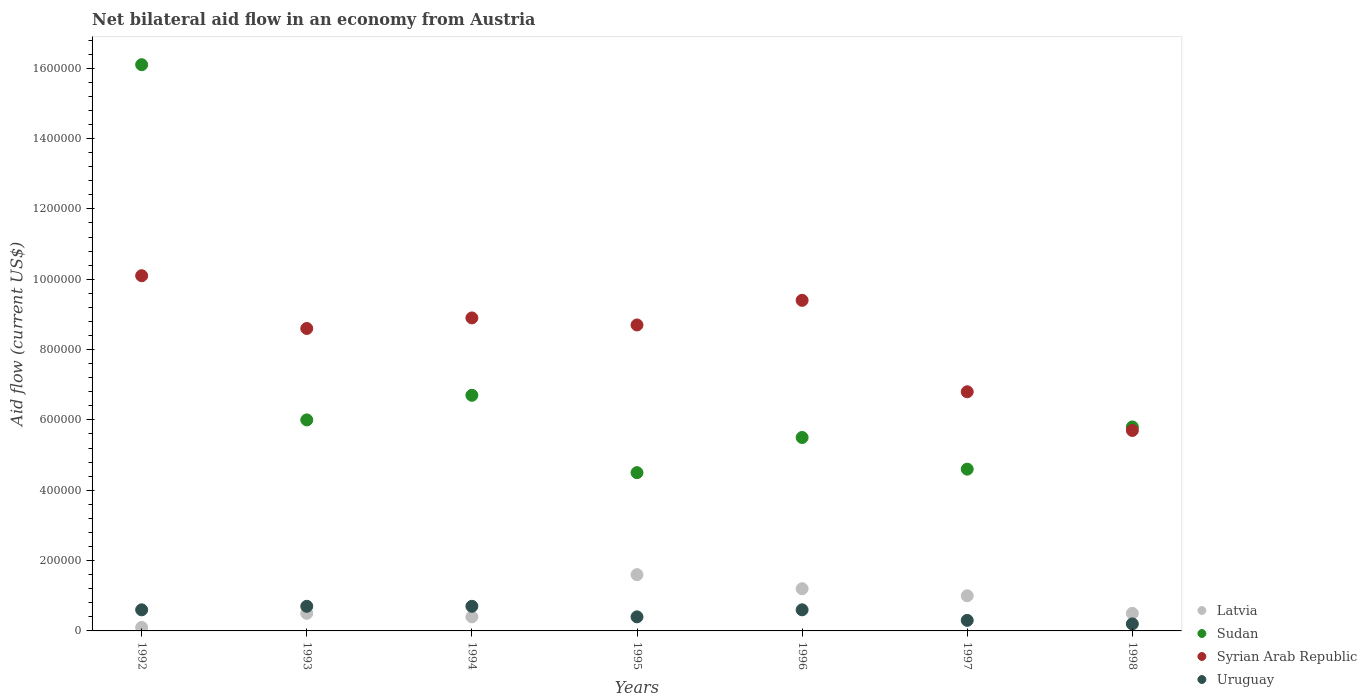Is the number of dotlines equal to the number of legend labels?
Give a very brief answer. Yes. What is the net bilateral aid flow in Syrian Arab Republic in 1997?
Provide a short and direct response. 6.80e+05. Across all years, what is the maximum net bilateral aid flow in Sudan?
Offer a terse response. 1.61e+06. Across all years, what is the minimum net bilateral aid flow in Sudan?
Offer a very short reply. 4.50e+05. In which year was the net bilateral aid flow in Sudan minimum?
Your answer should be very brief. 1995. What is the total net bilateral aid flow in Sudan in the graph?
Your response must be concise. 4.92e+06. What is the difference between the net bilateral aid flow in Uruguay in 1992 and that in 1998?
Offer a very short reply. 4.00e+04. What is the difference between the net bilateral aid flow in Sudan in 1998 and the net bilateral aid flow in Uruguay in 1994?
Keep it short and to the point. 5.10e+05. What is the average net bilateral aid flow in Latvia per year?
Offer a terse response. 7.57e+04. In the year 1998, what is the difference between the net bilateral aid flow in Syrian Arab Republic and net bilateral aid flow in Uruguay?
Your answer should be very brief. 5.50e+05. In how many years, is the net bilateral aid flow in Sudan greater than 880000 US$?
Your answer should be very brief. 1. What is the ratio of the net bilateral aid flow in Syrian Arab Republic in 1995 to that in 1998?
Your response must be concise. 1.53. Is the net bilateral aid flow in Sudan in 1993 less than that in 1998?
Your answer should be compact. No. What is the difference between the highest and the second highest net bilateral aid flow in Sudan?
Your answer should be very brief. 9.40e+05. What is the difference between the highest and the lowest net bilateral aid flow in Syrian Arab Republic?
Provide a succinct answer. 4.40e+05. In how many years, is the net bilateral aid flow in Uruguay greater than the average net bilateral aid flow in Uruguay taken over all years?
Your response must be concise. 4. Is it the case that in every year, the sum of the net bilateral aid flow in Syrian Arab Republic and net bilateral aid flow in Sudan  is greater than the sum of net bilateral aid flow in Uruguay and net bilateral aid flow in Latvia?
Offer a very short reply. Yes. Does the net bilateral aid flow in Sudan monotonically increase over the years?
Your answer should be very brief. No. Is the net bilateral aid flow in Uruguay strictly less than the net bilateral aid flow in Sudan over the years?
Your response must be concise. Yes. How many years are there in the graph?
Ensure brevity in your answer.  7. What is the difference between two consecutive major ticks on the Y-axis?
Your answer should be compact. 2.00e+05. Where does the legend appear in the graph?
Keep it short and to the point. Bottom right. How many legend labels are there?
Ensure brevity in your answer.  4. How are the legend labels stacked?
Your answer should be compact. Vertical. What is the title of the graph?
Keep it short and to the point. Net bilateral aid flow in an economy from Austria. Does "Netherlands" appear as one of the legend labels in the graph?
Give a very brief answer. No. What is the label or title of the Y-axis?
Offer a terse response. Aid flow (current US$). What is the Aid flow (current US$) in Sudan in 1992?
Offer a terse response. 1.61e+06. What is the Aid flow (current US$) in Syrian Arab Republic in 1992?
Your answer should be very brief. 1.01e+06. What is the Aid flow (current US$) of Latvia in 1993?
Your response must be concise. 5.00e+04. What is the Aid flow (current US$) in Syrian Arab Republic in 1993?
Give a very brief answer. 8.60e+05. What is the Aid flow (current US$) in Latvia in 1994?
Provide a short and direct response. 4.00e+04. What is the Aid flow (current US$) of Sudan in 1994?
Your answer should be very brief. 6.70e+05. What is the Aid flow (current US$) of Syrian Arab Republic in 1994?
Offer a very short reply. 8.90e+05. What is the Aid flow (current US$) of Latvia in 1995?
Your response must be concise. 1.60e+05. What is the Aid flow (current US$) in Sudan in 1995?
Provide a short and direct response. 4.50e+05. What is the Aid flow (current US$) of Syrian Arab Republic in 1995?
Make the answer very short. 8.70e+05. What is the Aid flow (current US$) in Uruguay in 1995?
Your answer should be compact. 4.00e+04. What is the Aid flow (current US$) of Sudan in 1996?
Give a very brief answer. 5.50e+05. What is the Aid flow (current US$) of Syrian Arab Republic in 1996?
Provide a short and direct response. 9.40e+05. What is the Aid flow (current US$) of Syrian Arab Republic in 1997?
Give a very brief answer. 6.80e+05. What is the Aid flow (current US$) in Uruguay in 1997?
Provide a short and direct response. 3.00e+04. What is the Aid flow (current US$) of Sudan in 1998?
Your answer should be compact. 5.80e+05. What is the Aid flow (current US$) in Syrian Arab Republic in 1998?
Provide a succinct answer. 5.70e+05. Across all years, what is the maximum Aid flow (current US$) in Sudan?
Provide a succinct answer. 1.61e+06. Across all years, what is the maximum Aid flow (current US$) of Syrian Arab Republic?
Provide a short and direct response. 1.01e+06. Across all years, what is the minimum Aid flow (current US$) of Latvia?
Your answer should be very brief. 10000. Across all years, what is the minimum Aid flow (current US$) in Sudan?
Your answer should be very brief. 4.50e+05. Across all years, what is the minimum Aid flow (current US$) of Syrian Arab Republic?
Keep it short and to the point. 5.70e+05. What is the total Aid flow (current US$) of Latvia in the graph?
Your answer should be compact. 5.30e+05. What is the total Aid flow (current US$) of Sudan in the graph?
Give a very brief answer. 4.92e+06. What is the total Aid flow (current US$) of Syrian Arab Republic in the graph?
Give a very brief answer. 5.82e+06. What is the total Aid flow (current US$) of Uruguay in the graph?
Ensure brevity in your answer.  3.50e+05. What is the difference between the Aid flow (current US$) in Sudan in 1992 and that in 1993?
Give a very brief answer. 1.01e+06. What is the difference between the Aid flow (current US$) of Syrian Arab Republic in 1992 and that in 1993?
Your response must be concise. 1.50e+05. What is the difference between the Aid flow (current US$) in Uruguay in 1992 and that in 1993?
Make the answer very short. -10000. What is the difference between the Aid flow (current US$) of Sudan in 1992 and that in 1994?
Provide a short and direct response. 9.40e+05. What is the difference between the Aid flow (current US$) of Uruguay in 1992 and that in 1994?
Provide a succinct answer. -10000. What is the difference between the Aid flow (current US$) in Sudan in 1992 and that in 1995?
Provide a succinct answer. 1.16e+06. What is the difference between the Aid flow (current US$) of Uruguay in 1992 and that in 1995?
Offer a terse response. 2.00e+04. What is the difference between the Aid flow (current US$) in Sudan in 1992 and that in 1996?
Your answer should be very brief. 1.06e+06. What is the difference between the Aid flow (current US$) in Syrian Arab Republic in 1992 and that in 1996?
Provide a succinct answer. 7.00e+04. What is the difference between the Aid flow (current US$) in Sudan in 1992 and that in 1997?
Give a very brief answer. 1.15e+06. What is the difference between the Aid flow (current US$) in Syrian Arab Republic in 1992 and that in 1997?
Offer a very short reply. 3.30e+05. What is the difference between the Aid flow (current US$) of Latvia in 1992 and that in 1998?
Your response must be concise. -4.00e+04. What is the difference between the Aid flow (current US$) in Sudan in 1992 and that in 1998?
Provide a short and direct response. 1.03e+06. What is the difference between the Aid flow (current US$) in Syrian Arab Republic in 1992 and that in 1998?
Your response must be concise. 4.40e+05. What is the difference between the Aid flow (current US$) in Uruguay in 1992 and that in 1998?
Offer a terse response. 4.00e+04. What is the difference between the Aid flow (current US$) in Latvia in 1993 and that in 1994?
Make the answer very short. 10000. What is the difference between the Aid flow (current US$) in Uruguay in 1993 and that in 1994?
Offer a terse response. 0. What is the difference between the Aid flow (current US$) of Sudan in 1993 and that in 1995?
Your response must be concise. 1.50e+05. What is the difference between the Aid flow (current US$) of Latvia in 1993 and that in 1996?
Ensure brevity in your answer.  -7.00e+04. What is the difference between the Aid flow (current US$) in Syrian Arab Republic in 1993 and that in 1996?
Ensure brevity in your answer.  -8.00e+04. What is the difference between the Aid flow (current US$) of Syrian Arab Republic in 1993 and that in 1997?
Provide a short and direct response. 1.80e+05. What is the difference between the Aid flow (current US$) of Uruguay in 1993 and that in 1997?
Your answer should be very brief. 4.00e+04. What is the difference between the Aid flow (current US$) of Latvia in 1993 and that in 1998?
Make the answer very short. 0. What is the difference between the Aid flow (current US$) of Syrian Arab Republic in 1993 and that in 1998?
Keep it short and to the point. 2.90e+05. What is the difference between the Aid flow (current US$) of Uruguay in 1993 and that in 1998?
Provide a short and direct response. 5.00e+04. What is the difference between the Aid flow (current US$) in Sudan in 1994 and that in 1995?
Your answer should be very brief. 2.20e+05. What is the difference between the Aid flow (current US$) in Syrian Arab Republic in 1994 and that in 1995?
Your answer should be very brief. 2.00e+04. What is the difference between the Aid flow (current US$) in Syrian Arab Republic in 1994 and that in 1996?
Offer a very short reply. -5.00e+04. What is the difference between the Aid flow (current US$) of Latvia in 1994 and that in 1997?
Your response must be concise. -6.00e+04. What is the difference between the Aid flow (current US$) of Sudan in 1994 and that in 1997?
Make the answer very short. 2.10e+05. What is the difference between the Aid flow (current US$) of Uruguay in 1994 and that in 1997?
Provide a succinct answer. 4.00e+04. What is the difference between the Aid flow (current US$) in Latvia in 1994 and that in 1998?
Your answer should be very brief. -10000. What is the difference between the Aid flow (current US$) in Sudan in 1994 and that in 1998?
Provide a succinct answer. 9.00e+04. What is the difference between the Aid flow (current US$) in Latvia in 1995 and that in 1996?
Offer a very short reply. 4.00e+04. What is the difference between the Aid flow (current US$) of Syrian Arab Republic in 1995 and that in 1996?
Provide a short and direct response. -7.00e+04. What is the difference between the Aid flow (current US$) of Latvia in 1995 and that in 1997?
Ensure brevity in your answer.  6.00e+04. What is the difference between the Aid flow (current US$) in Sudan in 1995 and that in 1998?
Offer a very short reply. -1.30e+05. What is the difference between the Aid flow (current US$) in Syrian Arab Republic in 1995 and that in 1998?
Provide a short and direct response. 3.00e+05. What is the difference between the Aid flow (current US$) of Sudan in 1996 and that in 1997?
Your answer should be very brief. 9.00e+04. What is the difference between the Aid flow (current US$) of Latvia in 1996 and that in 1998?
Ensure brevity in your answer.  7.00e+04. What is the difference between the Aid flow (current US$) of Uruguay in 1996 and that in 1998?
Provide a succinct answer. 4.00e+04. What is the difference between the Aid flow (current US$) of Latvia in 1997 and that in 1998?
Keep it short and to the point. 5.00e+04. What is the difference between the Aid flow (current US$) of Sudan in 1997 and that in 1998?
Give a very brief answer. -1.20e+05. What is the difference between the Aid flow (current US$) of Latvia in 1992 and the Aid flow (current US$) of Sudan in 1993?
Your response must be concise. -5.90e+05. What is the difference between the Aid flow (current US$) in Latvia in 1992 and the Aid flow (current US$) in Syrian Arab Republic in 1993?
Your answer should be compact. -8.50e+05. What is the difference between the Aid flow (current US$) of Sudan in 1992 and the Aid flow (current US$) of Syrian Arab Republic in 1993?
Give a very brief answer. 7.50e+05. What is the difference between the Aid flow (current US$) of Sudan in 1992 and the Aid flow (current US$) of Uruguay in 1993?
Provide a succinct answer. 1.54e+06. What is the difference between the Aid flow (current US$) of Syrian Arab Republic in 1992 and the Aid flow (current US$) of Uruguay in 1993?
Make the answer very short. 9.40e+05. What is the difference between the Aid flow (current US$) of Latvia in 1992 and the Aid flow (current US$) of Sudan in 1994?
Your answer should be very brief. -6.60e+05. What is the difference between the Aid flow (current US$) in Latvia in 1992 and the Aid flow (current US$) in Syrian Arab Republic in 1994?
Offer a very short reply. -8.80e+05. What is the difference between the Aid flow (current US$) of Sudan in 1992 and the Aid flow (current US$) of Syrian Arab Republic in 1994?
Provide a short and direct response. 7.20e+05. What is the difference between the Aid flow (current US$) of Sudan in 1992 and the Aid flow (current US$) of Uruguay in 1994?
Keep it short and to the point. 1.54e+06. What is the difference between the Aid flow (current US$) of Syrian Arab Republic in 1992 and the Aid flow (current US$) of Uruguay in 1994?
Your answer should be very brief. 9.40e+05. What is the difference between the Aid flow (current US$) of Latvia in 1992 and the Aid flow (current US$) of Sudan in 1995?
Offer a very short reply. -4.40e+05. What is the difference between the Aid flow (current US$) in Latvia in 1992 and the Aid flow (current US$) in Syrian Arab Republic in 1995?
Your response must be concise. -8.60e+05. What is the difference between the Aid flow (current US$) in Sudan in 1992 and the Aid flow (current US$) in Syrian Arab Republic in 1995?
Provide a succinct answer. 7.40e+05. What is the difference between the Aid flow (current US$) of Sudan in 1992 and the Aid flow (current US$) of Uruguay in 1995?
Provide a succinct answer. 1.57e+06. What is the difference between the Aid flow (current US$) of Syrian Arab Republic in 1992 and the Aid flow (current US$) of Uruguay in 1995?
Make the answer very short. 9.70e+05. What is the difference between the Aid flow (current US$) of Latvia in 1992 and the Aid flow (current US$) of Sudan in 1996?
Your answer should be very brief. -5.40e+05. What is the difference between the Aid flow (current US$) in Latvia in 1992 and the Aid flow (current US$) in Syrian Arab Republic in 1996?
Your response must be concise. -9.30e+05. What is the difference between the Aid flow (current US$) in Latvia in 1992 and the Aid flow (current US$) in Uruguay in 1996?
Offer a very short reply. -5.00e+04. What is the difference between the Aid flow (current US$) in Sudan in 1992 and the Aid flow (current US$) in Syrian Arab Republic in 1996?
Your answer should be compact. 6.70e+05. What is the difference between the Aid flow (current US$) in Sudan in 1992 and the Aid flow (current US$) in Uruguay in 1996?
Ensure brevity in your answer.  1.55e+06. What is the difference between the Aid flow (current US$) of Syrian Arab Republic in 1992 and the Aid flow (current US$) of Uruguay in 1996?
Provide a short and direct response. 9.50e+05. What is the difference between the Aid flow (current US$) of Latvia in 1992 and the Aid flow (current US$) of Sudan in 1997?
Provide a succinct answer. -4.50e+05. What is the difference between the Aid flow (current US$) of Latvia in 1992 and the Aid flow (current US$) of Syrian Arab Republic in 1997?
Make the answer very short. -6.70e+05. What is the difference between the Aid flow (current US$) of Latvia in 1992 and the Aid flow (current US$) of Uruguay in 1997?
Give a very brief answer. -2.00e+04. What is the difference between the Aid flow (current US$) in Sudan in 1992 and the Aid flow (current US$) in Syrian Arab Republic in 1997?
Offer a terse response. 9.30e+05. What is the difference between the Aid flow (current US$) of Sudan in 1992 and the Aid flow (current US$) of Uruguay in 1997?
Your response must be concise. 1.58e+06. What is the difference between the Aid flow (current US$) in Syrian Arab Republic in 1992 and the Aid flow (current US$) in Uruguay in 1997?
Provide a short and direct response. 9.80e+05. What is the difference between the Aid flow (current US$) in Latvia in 1992 and the Aid flow (current US$) in Sudan in 1998?
Your answer should be very brief. -5.70e+05. What is the difference between the Aid flow (current US$) of Latvia in 1992 and the Aid flow (current US$) of Syrian Arab Republic in 1998?
Make the answer very short. -5.60e+05. What is the difference between the Aid flow (current US$) of Latvia in 1992 and the Aid flow (current US$) of Uruguay in 1998?
Make the answer very short. -10000. What is the difference between the Aid flow (current US$) of Sudan in 1992 and the Aid flow (current US$) of Syrian Arab Republic in 1998?
Your response must be concise. 1.04e+06. What is the difference between the Aid flow (current US$) of Sudan in 1992 and the Aid flow (current US$) of Uruguay in 1998?
Your answer should be compact. 1.59e+06. What is the difference between the Aid flow (current US$) in Syrian Arab Republic in 1992 and the Aid flow (current US$) in Uruguay in 1998?
Your response must be concise. 9.90e+05. What is the difference between the Aid flow (current US$) in Latvia in 1993 and the Aid flow (current US$) in Sudan in 1994?
Make the answer very short. -6.20e+05. What is the difference between the Aid flow (current US$) in Latvia in 1993 and the Aid flow (current US$) in Syrian Arab Republic in 1994?
Provide a short and direct response. -8.40e+05. What is the difference between the Aid flow (current US$) in Sudan in 1993 and the Aid flow (current US$) in Uruguay in 1994?
Provide a short and direct response. 5.30e+05. What is the difference between the Aid flow (current US$) of Syrian Arab Republic in 1993 and the Aid flow (current US$) of Uruguay in 1994?
Your answer should be very brief. 7.90e+05. What is the difference between the Aid flow (current US$) in Latvia in 1993 and the Aid flow (current US$) in Sudan in 1995?
Keep it short and to the point. -4.00e+05. What is the difference between the Aid flow (current US$) of Latvia in 1993 and the Aid flow (current US$) of Syrian Arab Republic in 1995?
Keep it short and to the point. -8.20e+05. What is the difference between the Aid flow (current US$) of Latvia in 1993 and the Aid flow (current US$) of Uruguay in 1995?
Your answer should be compact. 10000. What is the difference between the Aid flow (current US$) of Sudan in 1993 and the Aid flow (current US$) of Uruguay in 1995?
Make the answer very short. 5.60e+05. What is the difference between the Aid flow (current US$) of Syrian Arab Republic in 1993 and the Aid flow (current US$) of Uruguay in 1995?
Keep it short and to the point. 8.20e+05. What is the difference between the Aid flow (current US$) in Latvia in 1993 and the Aid flow (current US$) in Sudan in 1996?
Give a very brief answer. -5.00e+05. What is the difference between the Aid flow (current US$) in Latvia in 1993 and the Aid flow (current US$) in Syrian Arab Republic in 1996?
Make the answer very short. -8.90e+05. What is the difference between the Aid flow (current US$) in Sudan in 1993 and the Aid flow (current US$) in Uruguay in 1996?
Offer a very short reply. 5.40e+05. What is the difference between the Aid flow (current US$) in Syrian Arab Republic in 1993 and the Aid flow (current US$) in Uruguay in 1996?
Keep it short and to the point. 8.00e+05. What is the difference between the Aid flow (current US$) in Latvia in 1993 and the Aid flow (current US$) in Sudan in 1997?
Offer a very short reply. -4.10e+05. What is the difference between the Aid flow (current US$) of Latvia in 1993 and the Aid flow (current US$) of Syrian Arab Republic in 1997?
Offer a terse response. -6.30e+05. What is the difference between the Aid flow (current US$) in Latvia in 1993 and the Aid flow (current US$) in Uruguay in 1997?
Your answer should be compact. 2.00e+04. What is the difference between the Aid flow (current US$) of Sudan in 1993 and the Aid flow (current US$) of Uruguay in 1997?
Keep it short and to the point. 5.70e+05. What is the difference between the Aid flow (current US$) in Syrian Arab Republic in 1993 and the Aid flow (current US$) in Uruguay in 1997?
Your answer should be compact. 8.30e+05. What is the difference between the Aid flow (current US$) of Latvia in 1993 and the Aid flow (current US$) of Sudan in 1998?
Offer a terse response. -5.30e+05. What is the difference between the Aid flow (current US$) of Latvia in 1993 and the Aid flow (current US$) of Syrian Arab Republic in 1998?
Make the answer very short. -5.20e+05. What is the difference between the Aid flow (current US$) in Sudan in 1993 and the Aid flow (current US$) in Syrian Arab Republic in 1998?
Ensure brevity in your answer.  3.00e+04. What is the difference between the Aid flow (current US$) in Sudan in 1993 and the Aid flow (current US$) in Uruguay in 1998?
Ensure brevity in your answer.  5.80e+05. What is the difference between the Aid flow (current US$) in Syrian Arab Republic in 1993 and the Aid flow (current US$) in Uruguay in 1998?
Make the answer very short. 8.40e+05. What is the difference between the Aid flow (current US$) in Latvia in 1994 and the Aid flow (current US$) in Sudan in 1995?
Your answer should be compact. -4.10e+05. What is the difference between the Aid flow (current US$) of Latvia in 1994 and the Aid flow (current US$) of Syrian Arab Republic in 1995?
Provide a short and direct response. -8.30e+05. What is the difference between the Aid flow (current US$) of Sudan in 1994 and the Aid flow (current US$) of Syrian Arab Republic in 1995?
Make the answer very short. -2.00e+05. What is the difference between the Aid flow (current US$) in Sudan in 1994 and the Aid flow (current US$) in Uruguay in 1995?
Give a very brief answer. 6.30e+05. What is the difference between the Aid flow (current US$) in Syrian Arab Republic in 1994 and the Aid flow (current US$) in Uruguay in 1995?
Offer a very short reply. 8.50e+05. What is the difference between the Aid flow (current US$) of Latvia in 1994 and the Aid flow (current US$) of Sudan in 1996?
Provide a succinct answer. -5.10e+05. What is the difference between the Aid flow (current US$) in Latvia in 1994 and the Aid flow (current US$) in Syrian Arab Republic in 1996?
Give a very brief answer. -9.00e+05. What is the difference between the Aid flow (current US$) in Sudan in 1994 and the Aid flow (current US$) in Syrian Arab Republic in 1996?
Offer a terse response. -2.70e+05. What is the difference between the Aid flow (current US$) of Syrian Arab Republic in 1994 and the Aid flow (current US$) of Uruguay in 1996?
Offer a terse response. 8.30e+05. What is the difference between the Aid flow (current US$) of Latvia in 1994 and the Aid flow (current US$) of Sudan in 1997?
Your response must be concise. -4.20e+05. What is the difference between the Aid flow (current US$) of Latvia in 1994 and the Aid flow (current US$) of Syrian Arab Republic in 1997?
Keep it short and to the point. -6.40e+05. What is the difference between the Aid flow (current US$) in Latvia in 1994 and the Aid flow (current US$) in Uruguay in 1997?
Ensure brevity in your answer.  10000. What is the difference between the Aid flow (current US$) of Sudan in 1994 and the Aid flow (current US$) of Uruguay in 1997?
Offer a terse response. 6.40e+05. What is the difference between the Aid flow (current US$) in Syrian Arab Republic in 1994 and the Aid flow (current US$) in Uruguay in 1997?
Make the answer very short. 8.60e+05. What is the difference between the Aid flow (current US$) in Latvia in 1994 and the Aid flow (current US$) in Sudan in 1998?
Your answer should be compact. -5.40e+05. What is the difference between the Aid flow (current US$) of Latvia in 1994 and the Aid flow (current US$) of Syrian Arab Republic in 1998?
Ensure brevity in your answer.  -5.30e+05. What is the difference between the Aid flow (current US$) of Sudan in 1994 and the Aid flow (current US$) of Syrian Arab Republic in 1998?
Ensure brevity in your answer.  1.00e+05. What is the difference between the Aid flow (current US$) in Sudan in 1994 and the Aid flow (current US$) in Uruguay in 1998?
Keep it short and to the point. 6.50e+05. What is the difference between the Aid flow (current US$) of Syrian Arab Republic in 1994 and the Aid flow (current US$) of Uruguay in 1998?
Make the answer very short. 8.70e+05. What is the difference between the Aid flow (current US$) of Latvia in 1995 and the Aid flow (current US$) of Sudan in 1996?
Make the answer very short. -3.90e+05. What is the difference between the Aid flow (current US$) of Latvia in 1995 and the Aid flow (current US$) of Syrian Arab Republic in 1996?
Ensure brevity in your answer.  -7.80e+05. What is the difference between the Aid flow (current US$) in Latvia in 1995 and the Aid flow (current US$) in Uruguay in 1996?
Provide a short and direct response. 1.00e+05. What is the difference between the Aid flow (current US$) of Sudan in 1995 and the Aid flow (current US$) of Syrian Arab Republic in 1996?
Ensure brevity in your answer.  -4.90e+05. What is the difference between the Aid flow (current US$) in Syrian Arab Republic in 1995 and the Aid flow (current US$) in Uruguay in 1996?
Make the answer very short. 8.10e+05. What is the difference between the Aid flow (current US$) of Latvia in 1995 and the Aid flow (current US$) of Syrian Arab Republic in 1997?
Your answer should be compact. -5.20e+05. What is the difference between the Aid flow (current US$) in Syrian Arab Republic in 1995 and the Aid flow (current US$) in Uruguay in 1997?
Your answer should be compact. 8.40e+05. What is the difference between the Aid flow (current US$) in Latvia in 1995 and the Aid flow (current US$) in Sudan in 1998?
Offer a very short reply. -4.20e+05. What is the difference between the Aid flow (current US$) of Latvia in 1995 and the Aid flow (current US$) of Syrian Arab Republic in 1998?
Keep it short and to the point. -4.10e+05. What is the difference between the Aid flow (current US$) of Sudan in 1995 and the Aid flow (current US$) of Uruguay in 1998?
Your answer should be compact. 4.30e+05. What is the difference between the Aid flow (current US$) in Syrian Arab Republic in 1995 and the Aid flow (current US$) in Uruguay in 1998?
Ensure brevity in your answer.  8.50e+05. What is the difference between the Aid flow (current US$) in Latvia in 1996 and the Aid flow (current US$) in Sudan in 1997?
Offer a very short reply. -3.40e+05. What is the difference between the Aid flow (current US$) in Latvia in 1996 and the Aid flow (current US$) in Syrian Arab Republic in 1997?
Give a very brief answer. -5.60e+05. What is the difference between the Aid flow (current US$) of Sudan in 1996 and the Aid flow (current US$) of Uruguay in 1997?
Offer a terse response. 5.20e+05. What is the difference between the Aid flow (current US$) in Syrian Arab Republic in 1996 and the Aid flow (current US$) in Uruguay in 1997?
Your answer should be very brief. 9.10e+05. What is the difference between the Aid flow (current US$) of Latvia in 1996 and the Aid flow (current US$) of Sudan in 1998?
Your response must be concise. -4.60e+05. What is the difference between the Aid flow (current US$) in Latvia in 1996 and the Aid flow (current US$) in Syrian Arab Republic in 1998?
Offer a terse response. -4.50e+05. What is the difference between the Aid flow (current US$) of Sudan in 1996 and the Aid flow (current US$) of Uruguay in 1998?
Provide a succinct answer. 5.30e+05. What is the difference between the Aid flow (current US$) in Syrian Arab Republic in 1996 and the Aid flow (current US$) in Uruguay in 1998?
Make the answer very short. 9.20e+05. What is the difference between the Aid flow (current US$) in Latvia in 1997 and the Aid flow (current US$) in Sudan in 1998?
Provide a short and direct response. -4.80e+05. What is the difference between the Aid flow (current US$) of Latvia in 1997 and the Aid flow (current US$) of Syrian Arab Republic in 1998?
Keep it short and to the point. -4.70e+05. What is the difference between the Aid flow (current US$) in Sudan in 1997 and the Aid flow (current US$) in Syrian Arab Republic in 1998?
Give a very brief answer. -1.10e+05. What is the difference between the Aid flow (current US$) of Sudan in 1997 and the Aid flow (current US$) of Uruguay in 1998?
Make the answer very short. 4.40e+05. What is the average Aid flow (current US$) of Latvia per year?
Keep it short and to the point. 7.57e+04. What is the average Aid flow (current US$) of Sudan per year?
Keep it short and to the point. 7.03e+05. What is the average Aid flow (current US$) of Syrian Arab Republic per year?
Offer a very short reply. 8.31e+05. In the year 1992, what is the difference between the Aid flow (current US$) in Latvia and Aid flow (current US$) in Sudan?
Offer a very short reply. -1.60e+06. In the year 1992, what is the difference between the Aid flow (current US$) of Latvia and Aid flow (current US$) of Syrian Arab Republic?
Your answer should be very brief. -1.00e+06. In the year 1992, what is the difference between the Aid flow (current US$) of Latvia and Aid flow (current US$) of Uruguay?
Make the answer very short. -5.00e+04. In the year 1992, what is the difference between the Aid flow (current US$) of Sudan and Aid flow (current US$) of Syrian Arab Republic?
Provide a succinct answer. 6.00e+05. In the year 1992, what is the difference between the Aid flow (current US$) in Sudan and Aid flow (current US$) in Uruguay?
Give a very brief answer. 1.55e+06. In the year 1992, what is the difference between the Aid flow (current US$) of Syrian Arab Republic and Aid flow (current US$) of Uruguay?
Make the answer very short. 9.50e+05. In the year 1993, what is the difference between the Aid flow (current US$) of Latvia and Aid flow (current US$) of Sudan?
Give a very brief answer. -5.50e+05. In the year 1993, what is the difference between the Aid flow (current US$) of Latvia and Aid flow (current US$) of Syrian Arab Republic?
Offer a very short reply. -8.10e+05. In the year 1993, what is the difference between the Aid flow (current US$) in Sudan and Aid flow (current US$) in Uruguay?
Your answer should be compact. 5.30e+05. In the year 1993, what is the difference between the Aid flow (current US$) in Syrian Arab Republic and Aid flow (current US$) in Uruguay?
Make the answer very short. 7.90e+05. In the year 1994, what is the difference between the Aid flow (current US$) of Latvia and Aid flow (current US$) of Sudan?
Give a very brief answer. -6.30e+05. In the year 1994, what is the difference between the Aid flow (current US$) in Latvia and Aid flow (current US$) in Syrian Arab Republic?
Provide a short and direct response. -8.50e+05. In the year 1994, what is the difference between the Aid flow (current US$) of Latvia and Aid flow (current US$) of Uruguay?
Make the answer very short. -3.00e+04. In the year 1994, what is the difference between the Aid flow (current US$) of Syrian Arab Republic and Aid flow (current US$) of Uruguay?
Keep it short and to the point. 8.20e+05. In the year 1995, what is the difference between the Aid flow (current US$) of Latvia and Aid flow (current US$) of Sudan?
Make the answer very short. -2.90e+05. In the year 1995, what is the difference between the Aid flow (current US$) in Latvia and Aid flow (current US$) in Syrian Arab Republic?
Keep it short and to the point. -7.10e+05. In the year 1995, what is the difference between the Aid flow (current US$) in Latvia and Aid flow (current US$) in Uruguay?
Provide a succinct answer. 1.20e+05. In the year 1995, what is the difference between the Aid flow (current US$) in Sudan and Aid flow (current US$) in Syrian Arab Republic?
Your response must be concise. -4.20e+05. In the year 1995, what is the difference between the Aid flow (current US$) in Syrian Arab Republic and Aid flow (current US$) in Uruguay?
Make the answer very short. 8.30e+05. In the year 1996, what is the difference between the Aid flow (current US$) of Latvia and Aid flow (current US$) of Sudan?
Make the answer very short. -4.30e+05. In the year 1996, what is the difference between the Aid flow (current US$) in Latvia and Aid flow (current US$) in Syrian Arab Republic?
Your answer should be compact. -8.20e+05. In the year 1996, what is the difference between the Aid flow (current US$) in Latvia and Aid flow (current US$) in Uruguay?
Make the answer very short. 6.00e+04. In the year 1996, what is the difference between the Aid flow (current US$) of Sudan and Aid flow (current US$) of Syrian Arab Republic?
Provide a succinct answer. -3.90e+05. In the year 1996, what is the difference between the Aid flow (current US$) of Sudan and Aid flow (current US$) of Uruguay?
Your answer should be very brief. 4.90e+05. In the year 1996, what is the difference between the Aid flow (current US$) in Syrian Arab Republic and Aid flow (current US$) in Uruguay?
Give a very brief answer. 8.80e+05. In the year 1997, what is the difference between the Aid flow (current US$) of Latvia and Aid flow (current US$) of Sudan?
Make the answer very short. -3.60e+05. In the year 1997, what is the difference between the Aid flow (current US$) in Latvia and Aid flow (current US$) in Syrian Arab Republic?
Offer a terse response. -5.80e+05. In the year 1997, what is the difference between the Aid flow (current US$) in Latvia and Aid flow (current US$) in Uruguay?
Make the answer very short. 7.00e+04. In the year 1997, what is the difference between the Aid flow (current US$) of Sudan and Aid flow (current US$) of Syrian Arab Republic?
Offer a very short reply. -2.20e+05. In the year 1997, what is the difference between the Aid flow (current US$) in Syrian Arab Republic and Aid flow (current US$) in Uruguay?
Your answer should be very brief. 6.50e+05. In the year 1998, what is the difference between the Aid flow (current US$) in Latvia and Aid flow (current US$) in Sudan?
Provide a short and direct response. -5.30e+05. In the year 1998, what is the difference between the Aid flow (current US$) of Latvia and Aid flow (current US$) of Syrian Arab Republic?
Your answer should be compact. -5.20e+05. In the year 1998, what is the difference between the Aid flow (current US$) in Sudan and Aid flow (current US$) in Uruguay?
Make the answer very short. 5.60e+05. What is the ratio of the Aid flow (current US$) of Latvia in 1992 to that in 1993?
Make the answer very short. 0.2. What is the ratio of the Aid flow (current US$) of Sudan in 1992 to that in 1993?
Make the answer very short. 2.68. What is the ratio of the Aid flow (current US$) of Syrian Arab Republic in 1992 to that in 1993?
Ensure brevity in your answer.  1.17. What is the ratio of the Aid flow (current US$) of Uruguay in 1992 to that in 1993?
Keep it short and to the point. 0.86. What is the ratio of the Aid flow (current US$) in Sudan in 1992 to that in 1994?
Provide a short and direct response. 2.4. What is the ratio of the Aid flow (current US$) in Syrian Arab Republic in 1992 to that in 1994?
Offer a very short reply. 1.13. What is the ratio of the Aid flow (current US$) of Uruguay in 1992 to that in 1994?
Your response must be concise. 0.86. What is the ratio of the Aid flow (current US$) in Latvia in 1992 to that in 1995?
Ensure brevity in your answer.  0.06. What is the ratio of the Aid flow (current US$) of Sudan in 1992 to that in 1995?
Offer a terse response. 3.58. What is the ratio of the Aid flow (current US$) of Syrian Arab Republic in 1992 to that in 1995?
Give a very brief answer. 1.16. What is the ratio of the Aid flow (current US$) in Uruguay in 1992 to that in 1995?
Make the answer very short. 1.5. What is the ratio of the Aid flow (current US$) in Latvia in 1992 to that in 1996?
Offer a terse response. 0.08. What is the ratio of the Aid flow (current US$) in Sudan in 1992 to that in 1996?
Offer a very short reply. 2.93. What is the ratio of the Aid flow (current US$) of Syrian Arab Republic in 1992 to that in 1996?
Offer a very short reply. 1.07. What is the ratio of the Aid flow (current US$) in Latvia in 1992 to that in 1997?
Provide a succinct answer. 0.1. What is the ratio of the Aid flow (current US$) in Sudan in 1992 to that in 1997?
Offer a terse response. 3.5. What is the ratio of the Aid flow (current US$) in Syrian Arab Republic in 1992 to that in 1997?
Give a very brief answer. 1.49. What is the ratio of the Aid flow (current US$) in Uruguay in 1992 to that in 1997?
Provide a short and direct response. 2. What is the ratio of the Aid flow (current US$) of Sudan in 1992 to that in 1998?
Give a very brief answer. 2.78. What is the ratio of the Aid flow (current US$) of Syrian Arab Republic in 1992 to that in 1998?
Provide a succinct answer. 1.77. What is the ratio of the Aid flow (current US$) in Sudan in 1993 to that in 1994?
Keep it short and to the point. 0.9. What is the ratio of the Aid flow (current US$) of Syrian Arab Republic in 1993 to that in 1994?
Keep it short and to the point. 0.97. What is the ratio of the Aid flow (current US$) in Latvia in 1993 to that in 1995?
Your response must be concise. 0.31. What is the ratio of the Aid flow (current US$) of Sudan in 1993 to that in 1995?
Provide a succinct answer. 1.33. What is the ratio of the Aid flow (current US$) in Uruguay in 1993 to that in 1995?
Provide a short and direct response. 1.75. What is the ratio of the Aid flow (current US$) of Latvia in 1993 to that in 1996?
Your response must be concise. 0.42. What is the ratio of the Aid flow (current US$) in Syrian Arab Republic in 1993 to that in 1996?
Give a very brief answer. 0.91. What is the ratio of the Aid flow (current US$) in Uruguay in 1993 to that in 1996?
Ensure brevity in your answer.  1.17. What is the ratio of the Aid flow (current US$) in Sudan in 1993 to that in 1997?
Your answer should be compact. 1.3. What is the ratio of the Aid flow (current US$) of Syrian Arab Republic in 1993 to that in 1997?
Give a very brief answer. 1.26. What is the ratio of the Aid flow (current US$) in Uruguay in 1993 to that in 1997?
Your answer should be very brief. 2.33. What is the ratio of the Aid flow (current US$) of Latvia in 1993 to that in 1998?
Give a very brief answer. 1. What is the ratio of the Aid flow (current US$) of Sudan in 1993 to that in 1998?
Your response must be concise. 1.03. What is the ratio of the Aid flow (current US$) of Syrian Arab Republic in 1993 to that in 1998?
Keep it short and to the point. 1.51. What is the ratio of the Aid flow (current US$) in Latvia in 1994 to that in 1995?
Provide a succinct answer. 0.25. What is the ratio of the Aid flow (current US$) in Sudan in 1994 to that in 1995?
Make the answer very short. 1.49. What is the ratio of the Aid flow (current US$) in Uruguay in 1994 to that in 1995?
Ensure brevity in your answer.  1.75. What is the ratio of the Aid flow (current US$) in Latvia in 1994 to that in 1996?
Give a very brief answer. 0.33. What is the ratio of the Aid flow (current US$) of Sudan in 1994 to that in 1996?
Ensure brevity in your answer.  1.22. What is the ratio of the Aid flow (current US$) in Syrian Arab Republic in 1994 to that in 1996?
Make the answer very short. 0.95. What is the ratio of the Aid flow (current US$) in Sudan in 1994 to that in 1997?
Your answer should be compact. 1.46. What is the ratio of the Aid flow (current US$) of Syrian Arab Republic in 1994 to that in 1997?
Ensure brevity in your answer.  1.31. What is the ratio of the Aid flow (current US$) of Uruguay in 1994 to that in 1997?
Offer a terse response. 2.33. What is the ratio of the Aid flow (current US$) in Latvia in 1994 to that in 1998?
Your response must be concise. 0.8. What is the ratio of the Aid flow (current US$) in Sudan in 1994 to that in 1998?
Ensure brevity in your answer.  1.16. What is the ratio of the Aid flow (current US$) in Syrian Arab Republic in 1994 to that in 1998?
Your answer should be very brief. 1.56. What is the ratio of the Aid flow (current US$) in Latvia in 1995 to that in 1996?
Keep it short and to the point. 1.33. What is the ratio of the Aid flow (current US$) of Sudan in 1995 to that in 1996?
Offer a very short reply. 0.82. What is the ratio of the Aid flow (current US$) of Syrian Arab Republic in 1995 to that in 1996?
Your answer should be compact. 0.93. What is the ratio of the Aid flow (current US$) of Latvia in 1995 to that in 1997?
Give a very brief answer. 1.6. What is the ratio of the Aid flow (current US$) in Sudan in 1995 to that in 1997?
Make the answer very short. 0.98. What is the ratio of the Aid flow (current US$) in Syrian Arab Republic in 1995 to that in 1997?
Offer a very short reply. 1.28. What is the ratio of the Aid flow (current US$) of Sudan in 1995 to that in 1998?
Provide a succinct answer. 0.78. What is the ratio of the Aid flow (current US$) of Syrian Arab Republic in 1995 to that in 1998?
Keep it short and to the point. 1.53. What is the ratio of the Aid flow (current US$) of Uruguay in 1995 to that in 1998?
Keep it short and to the point. 2. What is the ratio of the Aid flow (current US$) in Latvia in 1996 to that in 1997?
Give a very brief answer. 1.2. What is the ratio of the Aid flow (current US$) of Sudan in 1996 to that in 1997?
Offer a terse response. 1.2. What is the ratio of the Aid flow (current US$) in Syrian Arab Republic in 1996 to that in 1997?
Your response must be concise. 1.38. What is the ratio of the Aid flow (current US$) in Sudan in 1996 to that in 1998?
Your answer should be compact. 0.95. What is the ratio of the Aid flow (current US$) in Syrian Arab Republic in 1996 to that in 1998?
Your answer should be very brief. 1.65. What is the ratio of the Aid flow (current US$) of Uruguay in 1996 to that in 1998?
Your answer should be very brief. 3. What is the ratio of the Aid flow (current US$) in Latvia in 1997 to that in 1998?
Offer a very short reply. 2. What is the ratio of the Aid flow (current US$) of Sudan in 1997 to that in 1998?
Make the answer very short. 0.79. What is the ratio of the Aid flow (current US$) in Syrian Arab Republic in 1997 to that in 1998?
Ensure brevity in your answer.  1.19. What is the difference between the highest and the second highest Aid flow (current US$) of Latvia?
Ensure brevity in your answer.  4.00e+04. What is the difference between the highest and the second highest Aid flow (current US$) in Sudan?
Your answer should be compact. 9.40e+05. What is the difference between the highest and the lowest Aid flow (current US$) in Latvia?
Make the answer very short. 1.50e+05. What is the difference between the highest and the lowest Aid flow (current US$) of Sudan?
Your response must be concise. 1.16e+06. What is the difference between the highest and the lowest Aid flow (current US$) of Uruguay?
Give a very brief answer. 5.00e+04. 